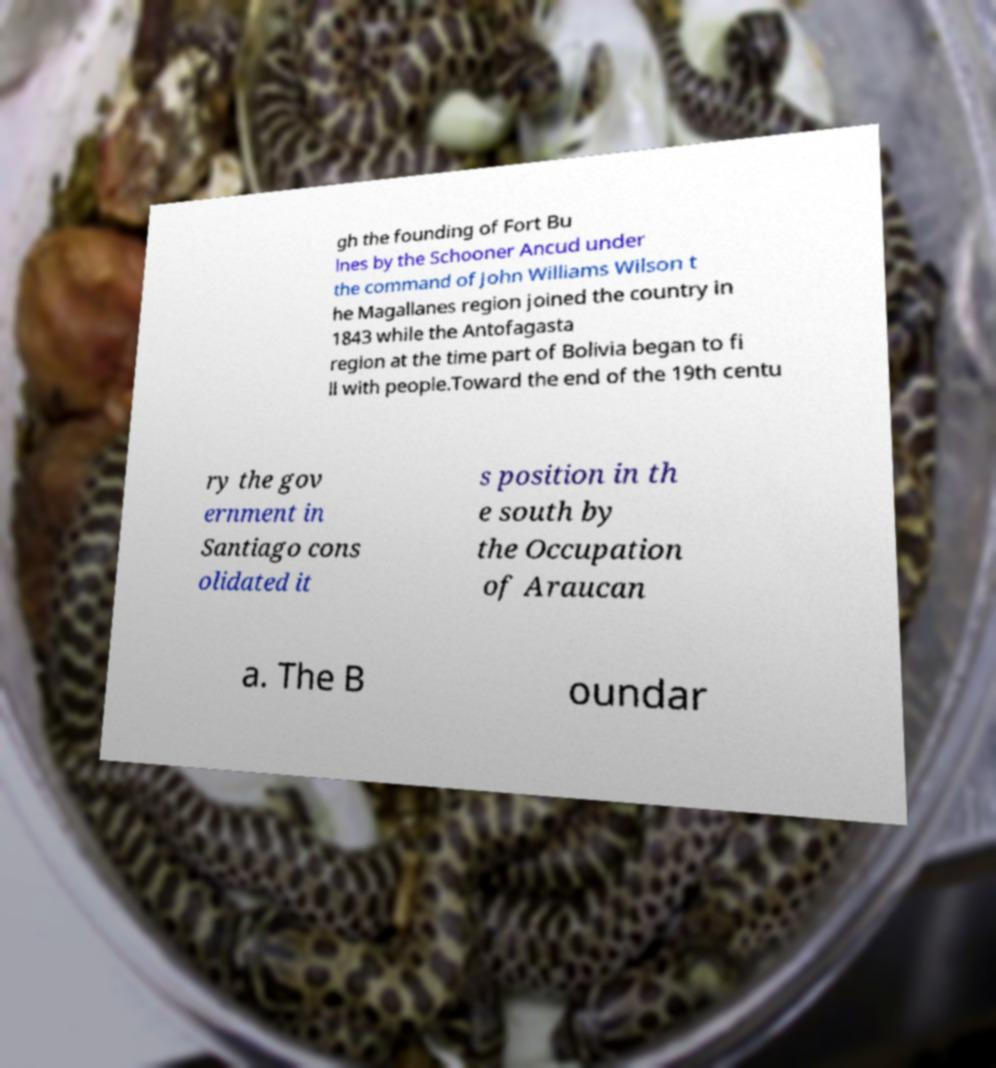I need the written content from this picture converted into text. Can you do that? gh the founding of Fort Bu lnes by the Schooner Ancud under the command of John Williams Wilson t he Magallanes region joined the country in 1843 while the Antofagasta region at the time part of Bolivia began to fi ll with people.Toward the end of the 19th centu ry the gov ernment in Santiago cons olidated it s position in th e south by the Occupation of Araucan a. The B oundar 